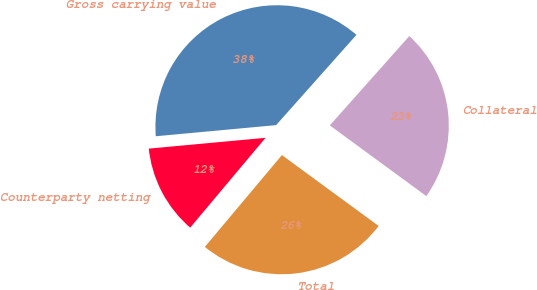<chart> <loc_0><loc_0><loc_500><loc_500><pie_chart><fcel>Gross carrying value<fcel>Counterparty netting<fcel>Total<fcel>Collateral<nl><fcel>38.05%<fcel>12.42%<fcel>26.05%<fcel>23.49%<nl></chart> 